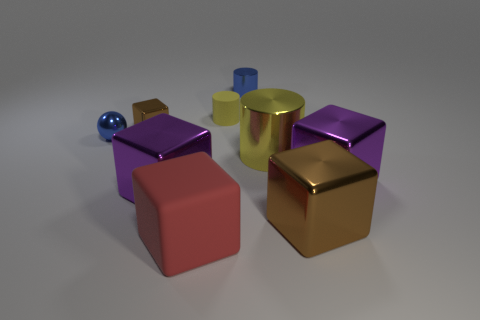Subtract all red cubes. How many cubes are left? 4 Subtract all small brown metal cubes. How many cubes are left? 4 Subtract all gray cubes. Subtract all gray cylinders. How many cubes are left? 5 Subtract all cubes. How many objects are left? 4 Subtract all small metal balls. Subtract all small blue balls. How many objects are left? 7 Add 7 big yellow metallic objects. How many big yellow metallic objects are left? 8 Add 6 big brown metallic blocks. How many big brown metallic blocks exist? 7 Subtract 1 red blocks. How many objects are left? 8 